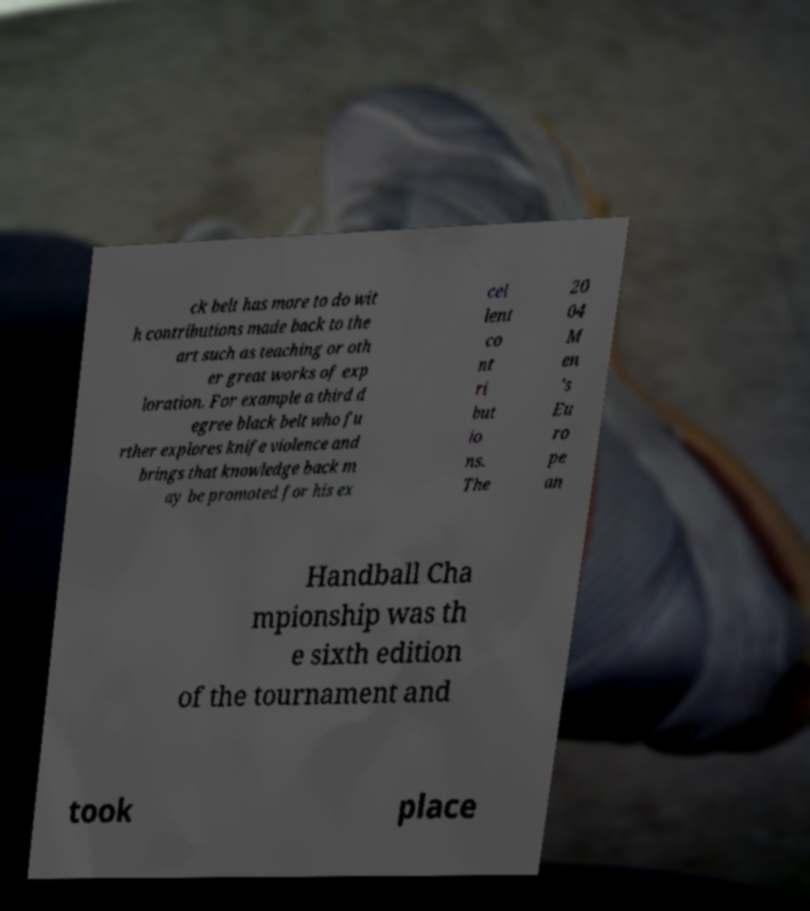Can you read and provide the text displayed in the image?This photo seems to have some interesting text. Can you extract and type it out for me? ck belt has more to do wit h contributions made back to the art such as teaching or oth er great works of exp loration. For example a third d egree black belt who fu rther explores knife violence and brings that knowledge back m ay be promoted for his ex cel lent co nt ri but io ns. The 20 04 M en 's Eu ro pe an Handball Cha mpionship was th e sixth edition of the tournament and took place 